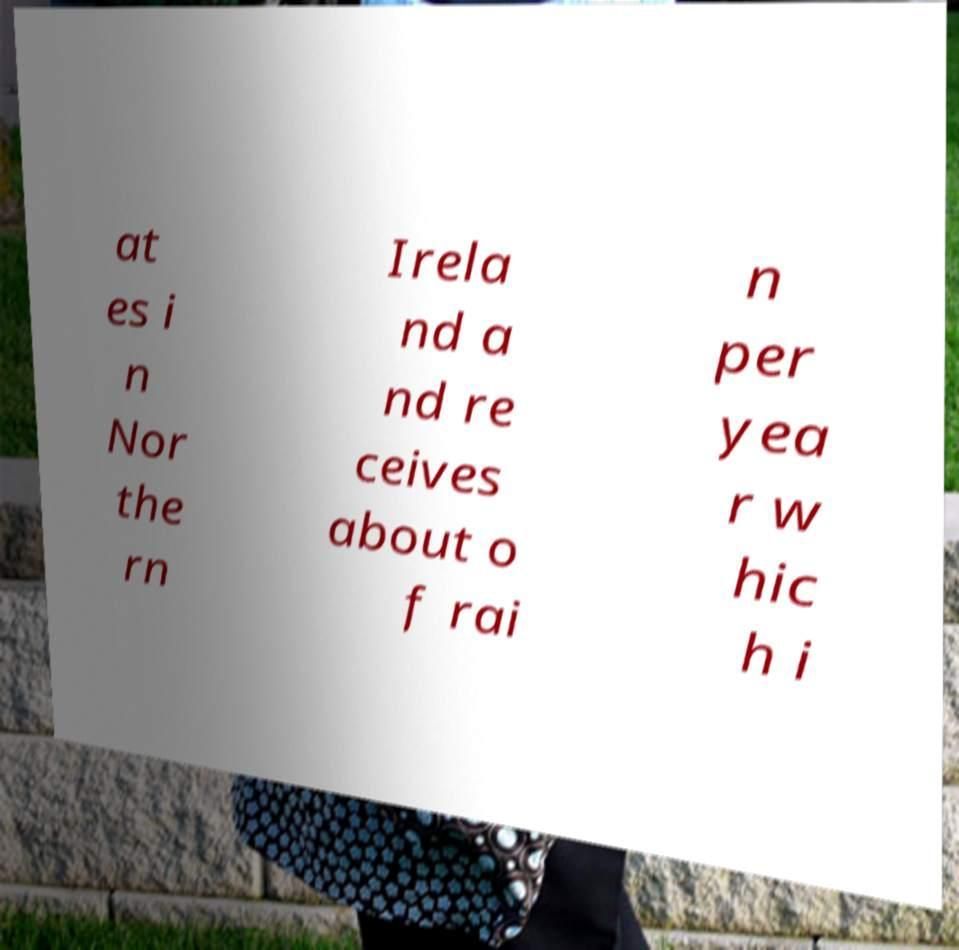There's text embedded in this image that I need extracted. Can you transcribe it verbatim? at es i n Nor the rn Irela nd a nd re ceives about o f rai n per yea r w hic h i 